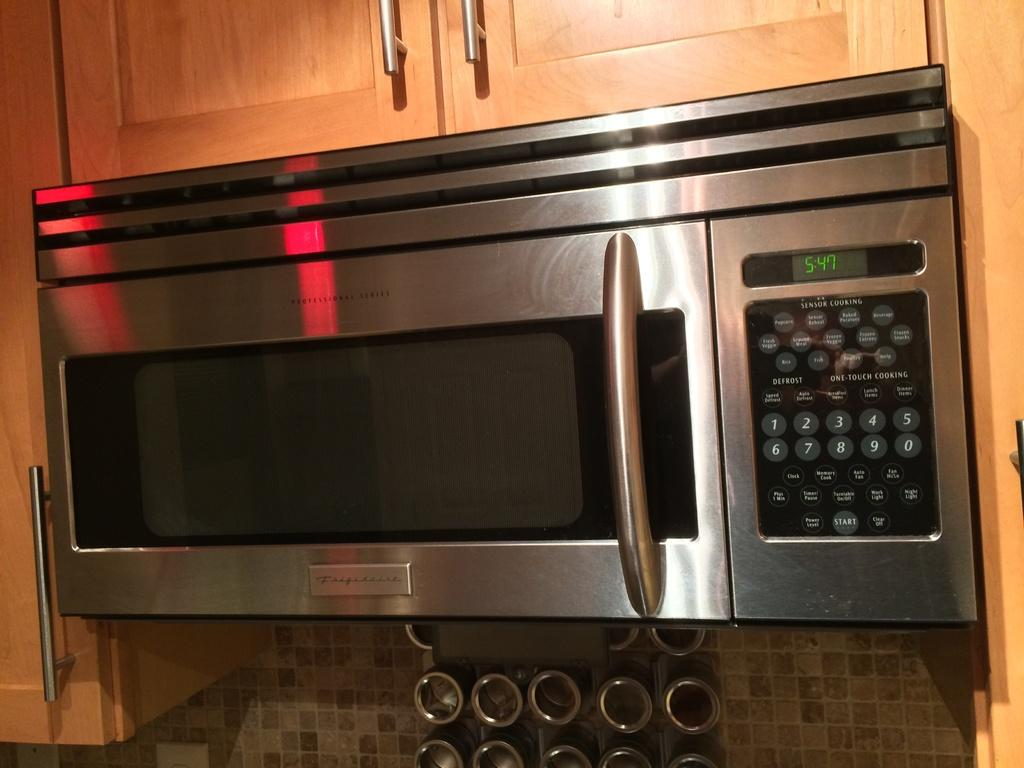<image>
Share a concise interpretation of the image provided. a microwave oven hung under cabinets with the time reading 5:47 